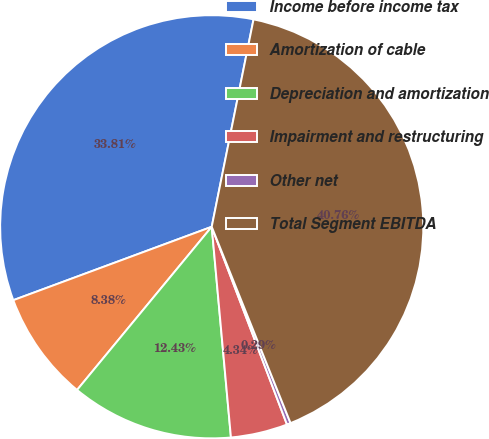Convert chart to OTSL. <chart><loc_0><loc_0><loc_500><loc_500><pie_chart><fcel>Income before income tax<fcel>Amortization of cable<fcel>Depreciation and amortization<fcel>Impairment and restructuring<fcel>Other net<fcel>Total Segment EBITDA<nl><fcel>33.81%<fcel>8.38%<fcel>12.43%<fcel>4.34%<fcel>0.29%<fcel>40.76%<nl></chart> 